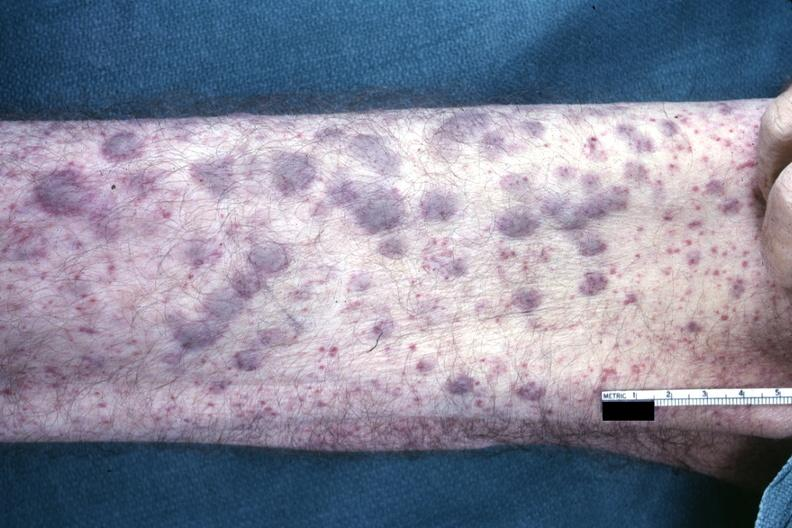s teeth said to be infiltrates of aml?
Answer the question using a single word or phrase. No 